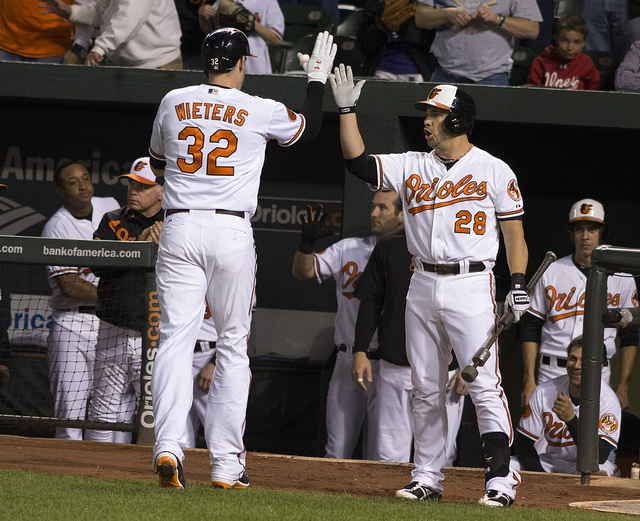Describe the objects in this image and their specific colors. I can see people in maroon, lavender, black, darkgray, and gray tones, people in maroon, lavender, darkgray, black, and gray tones, people in maroon, black, gray, and darkgray tones, people in maroon, black, darkgray, and gray tones, and people in maroon, black, gray, darkgray, and lavender tones in this image. 